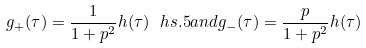<formula> <loc_0><loc_0><loc_500><loc_500>g _ { + } ( \tau ) = \frac { 1 } { 1 + p ^ { 2 } } h ( \tau ) \ h s { . 5 } a n d g _ { - } ( \tau ) = \frac { p } { 1 + p ^ { 2 } } h ( \tau )</formula> 